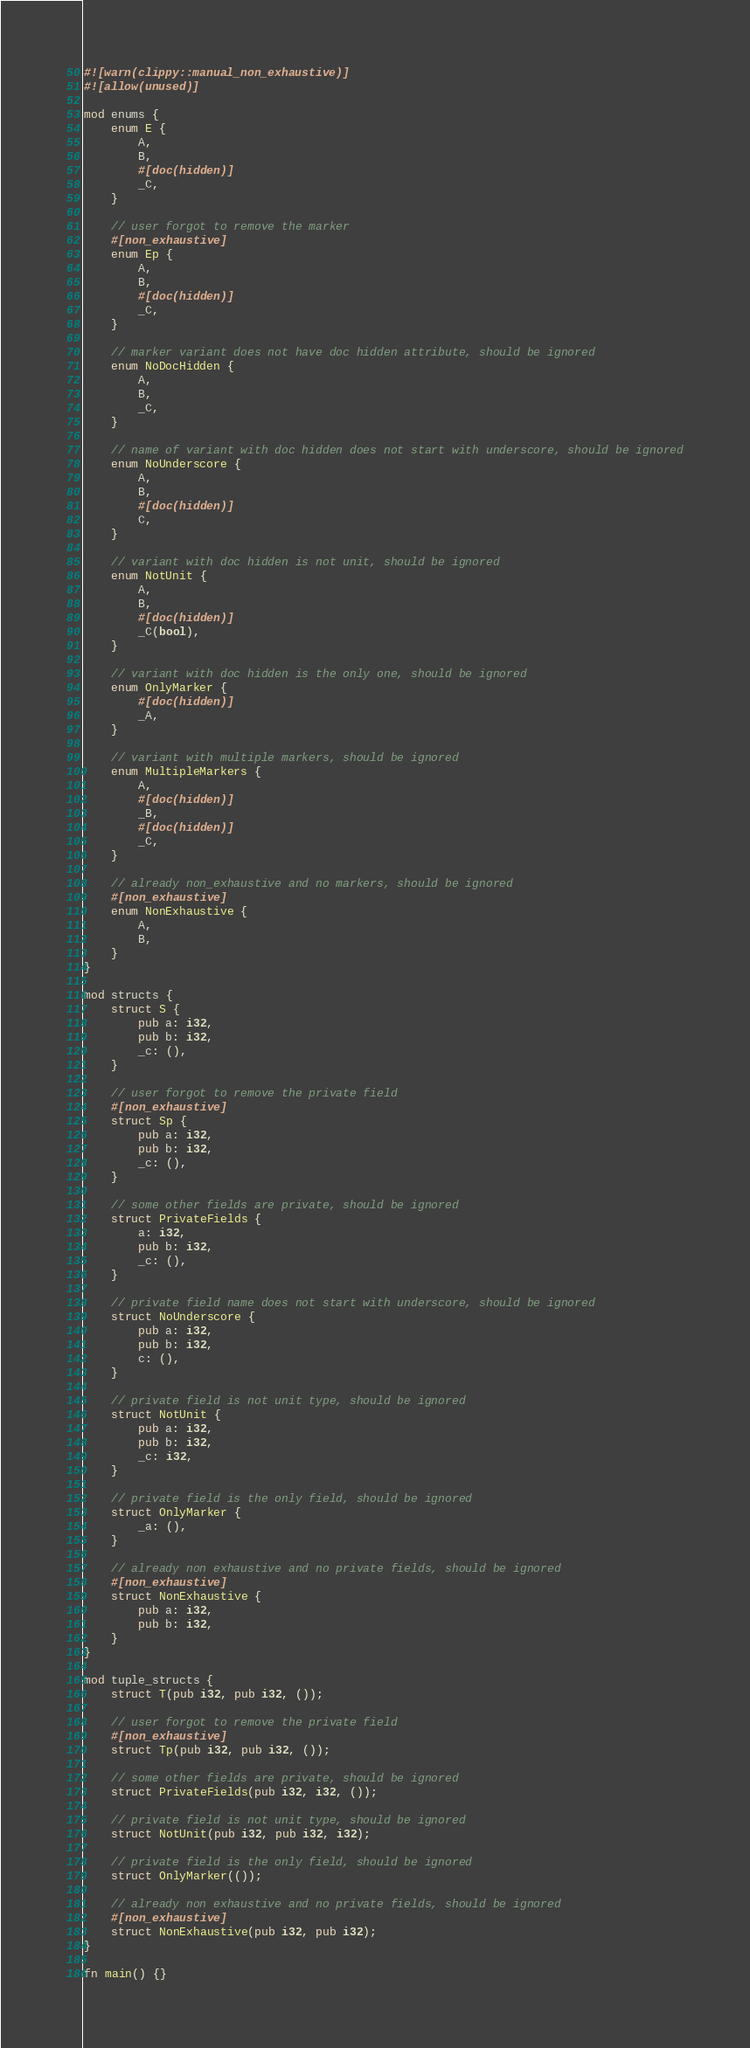<code> <loc_0><loc_0><loc_500><loc_500><_Rust_>#![warn(clippy::manual_non_exhaustive)]
#![allow(unused)]

mod enums {
    enum E {
        A,
        B,
        #[doc(hidden)]
        _C,
    }

    // user forgot to remove the marker
    #[non_exhaustive]
    enum Ep {
        A,
        B,
        #[doc(hidden)]
        _C,
    }

    // marker variant does not have doc hidden attribute, should be ignored
    enum NoDocHidden {
        A,
        B,
        _C,
    }

    // name of variant with doc hidden does not start with underscore, should be ignored
    enum NoUnderscore {
        A,
        B,
        #[doc(hidden)]
        C,
    }

    // variant with doc hidden is not unit, should be ignored
    enum NotUnit {
        A,
        B,
        #[doc(hidden)]
        _C(bool),
    }

    // variant with doc hidden is the only one, should be ignored
    enum OnlyMarker {
        #[doc(hidden)]
        _A,
    }

    // variant with multiple markers, should be ignored
    enum MultipleMarkers {
        A,
        #[doc(hidden)]
        _B,
        #[doc(hidden)]
        _C,
    }

    // already non_exhaustive and no markers, should be ignored
    #[non_exhaustive]
    enum NonExhaustive {
        A,
        B,
    }
}

mod structs {
    struct S {
        pub a: i32,
        pub b: i32,
        _c: (),
    }

    // user forgot to remove the private field
    #[non_exhaustive]
    struct Sp {
        pub a: i32,
        pub b: i32,
        _c: (),
    }

    // some other fields are private, should be ignored
    struct PrivateFields {
        a: i32,
        pub b: i32,
        _c: (),
    }

    // private field name does not start with underscore, should be ignored
    struct NoUnderscore {
        pub a: i32,
        pub b: i32,
        c: (),
    }

    // private field is not unit type, should be ignored
    struct NotUnit {
        pub a: i32,
        pub b: i32,
        _c: i32,
    }

    // private field is the only field, should be ignored
    struct OnlyMarker {
        _a: (),
    }

    // already non exhaustive and no private fields, should be ignored
    #[non_exhaustive]
    struct NonExhaustive {
        pub a: i32,
        pub b: i32,
    }
}

mod tuple_structs {
    struct T(pub i32, pub i32, ());

    // user forgot to remove the private field
    #[non_exhaustive]
    struct Tp(pub i32, pub i32, ());

    // some other fields are private, should be ignored
    struct PrivateFields(pub i32, i32, ());

    // private field is not unit type, should be ignored
    struct NotUnit(pub i32, pub i32, i32);

    // private field is the only field, should be ignored
    struct OnlyMarker(());

    // already non exhaustive and no private fields, should be ignored
    #[non_exhaustive]
    struct NonExhaustive(pub i32, pub i32);
}

fn main() {}
</code> 